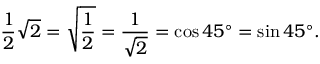Convert formula to latex. <formula><loc_0><loc_0><loc_500><loc_500>{ \frac { 1 } { 2 } } { \sqrt { 2 } } = { \sqrt { \frac { 1 } { 2 } } } = { \frac { 1 } { \sqrt { 2 } } } = \cos 4 5 ^ { \circ } = \sin 4 5 ^ { \circ } .</formula> 